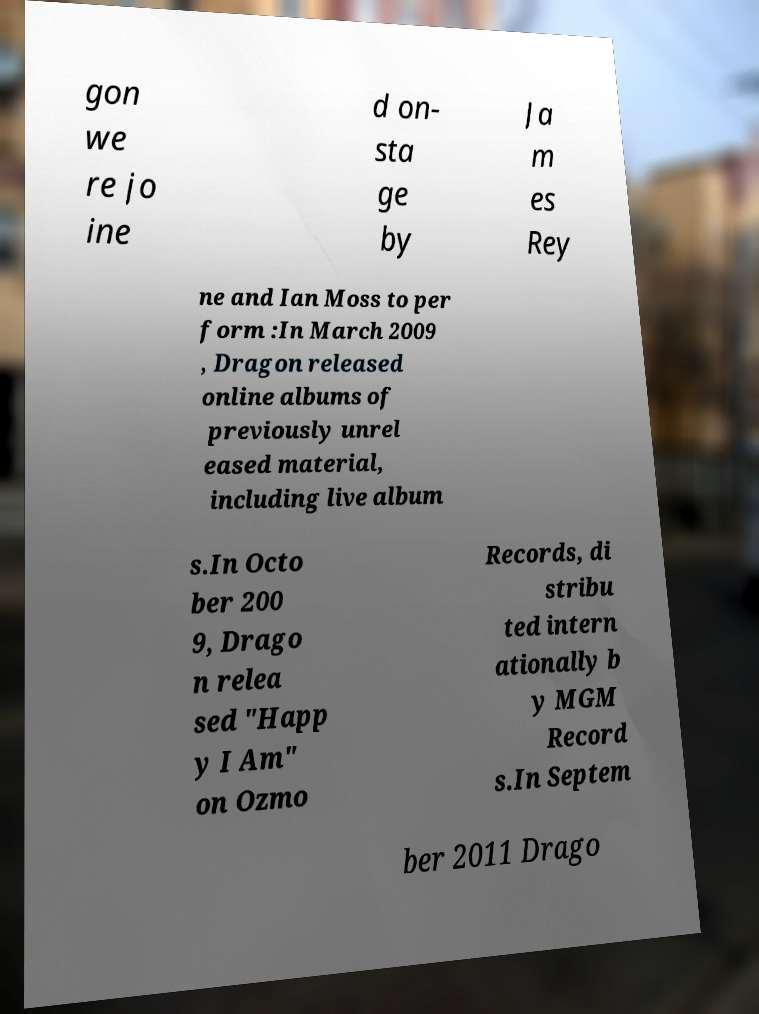Can you accurately transcribe the text from the provided image for me? gon we re jo ine d on- sta ge by Ja m es Rey ne and Ian Moss to per form :In March 2009 , Dragon released online albums of previously unrel eased material, including live album s.In Octo ber 200 9, Drago n relea sed "Happ y I Am" on Ozmo Records, di stribu ted intern ationally b y MGM Record s.In Septem ber 2011 Drago 